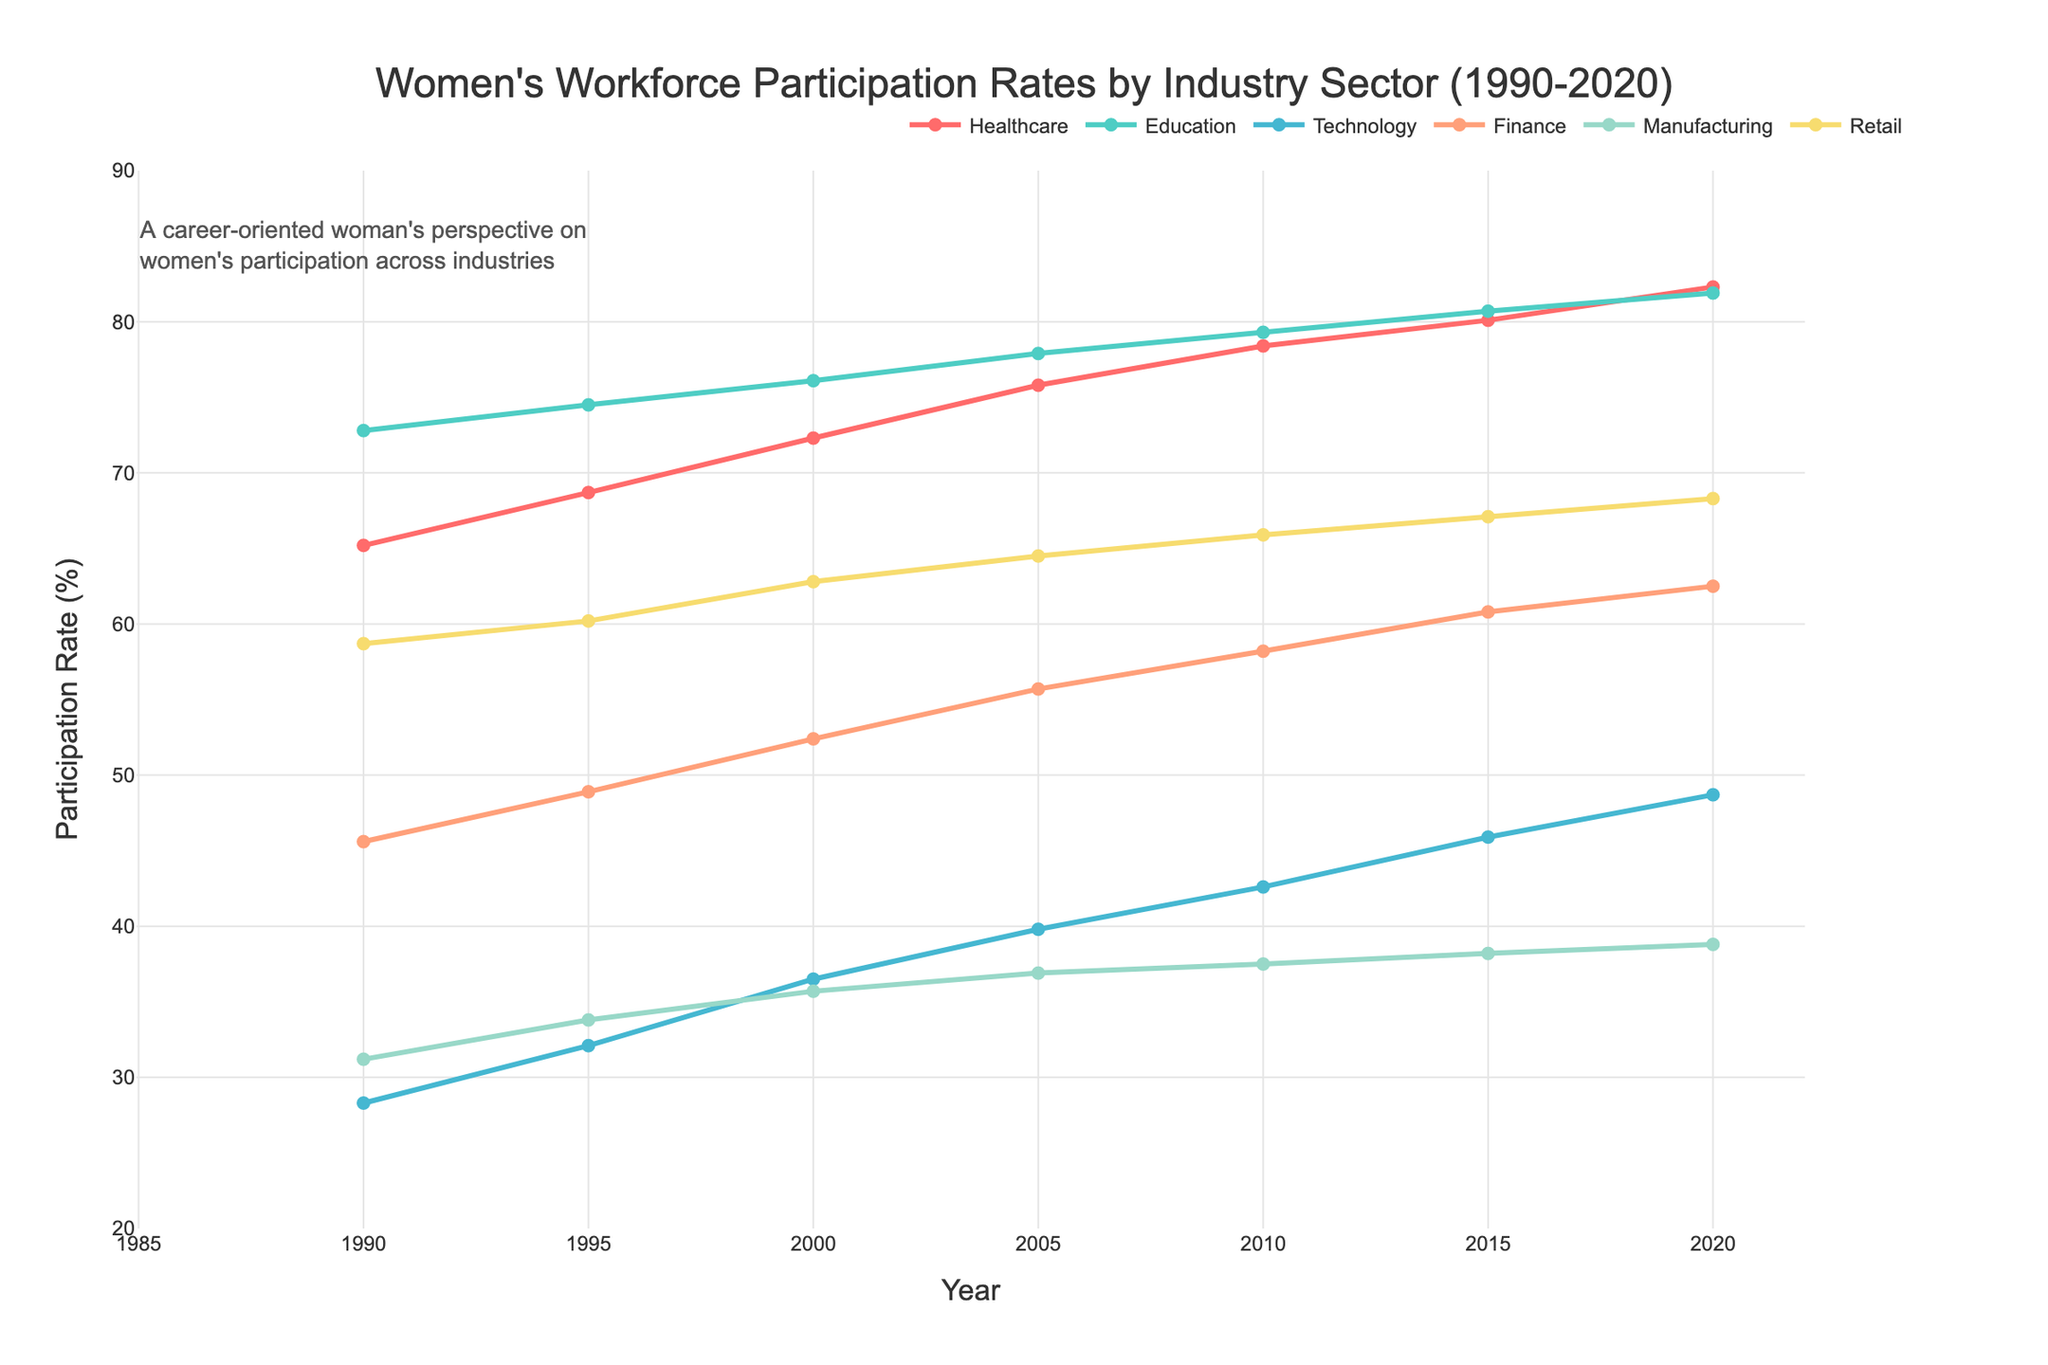What was the women's workforce participation rate in Healthcare in 1990? Look at the line corresponding to Healthcare and find the value at the year 1990.
Answer: 65.2% Which industry sector had the highest women's workforce participation rate in 2020? Compare the values for all industry sectors in 2020 and identify the maximum.
Answer: Education By how many percentage points did the women's participation rate in the Technology sector increase from 1990 to 2020? Subtract the participation rate in 1990 from that in 2020 for the Technology sector (48.7 - 28.3).
Answer: 20.4 percentage points Between which two adjacent years was the increase in the women's participation rate in Finance the greatest? Calculate the differences in the participation rates for Finance between each pair of adjacent years and identify the greatest difference. The differences are 1995-1990 (3.3), 2000-1995 (3.5), 2005-2000 (3.3), 2010-2005 (2.5), 2015-2010 (2.6), 2020-2015 (1.7).
Answer: 2000 and 2005 Which sector showed the least growth in women's participation rate over the entire period? Compare the growth (difference between the rates in 2020 and 1990) for each sector. Healthcare (17.1), Education (9.1), Technology (20.4), Finance (16.9), Manufacturing (7.6), Retail (9.6). The sector with the smallest growth is Manufacturing.
Answer: Manufacturing Which two sectors had the most similar women's workforce participation rates in 2010? Compare the participation rates for all sectors in 2010 and find those that are closest.
Answer: Manufacturing and Retail (37.5 and 65.9 are closest) 